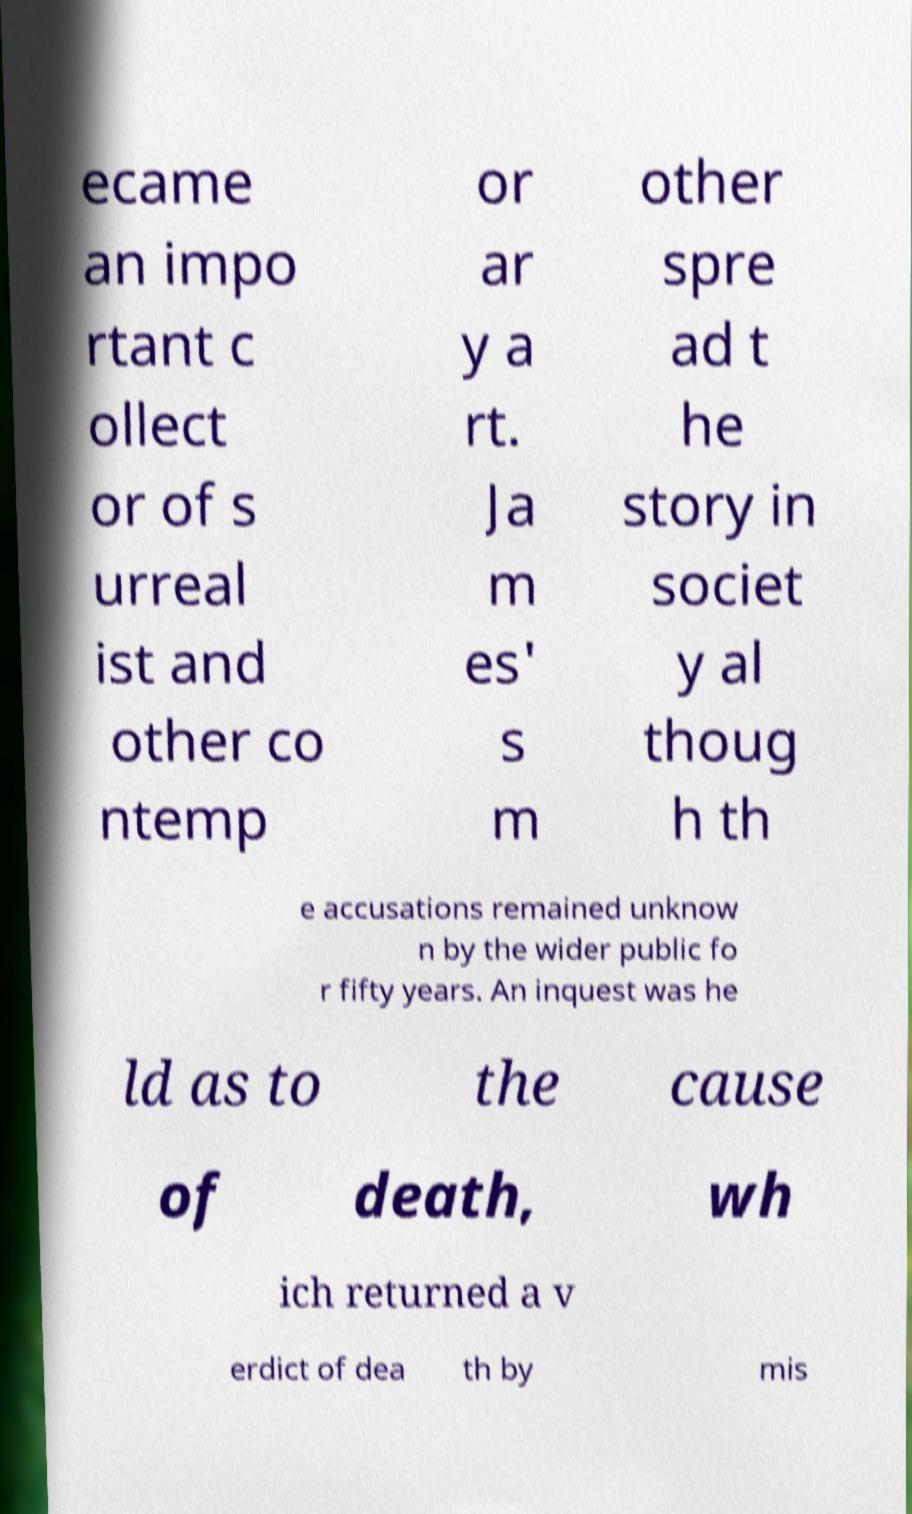Could you assist in decoding the text presented in this image and type it out clearly? ecame an impo rtant c ollect or of s urreal ist and other co ntemp or ar y a rt. Ja m es' s m other spre ad t he story in societ y al thoug h th e accusations remained unknow n by the wider public fo r fifty years. An inquest was he ld as to the cause of death, wh ich returned a v erdict of dea th by mis 